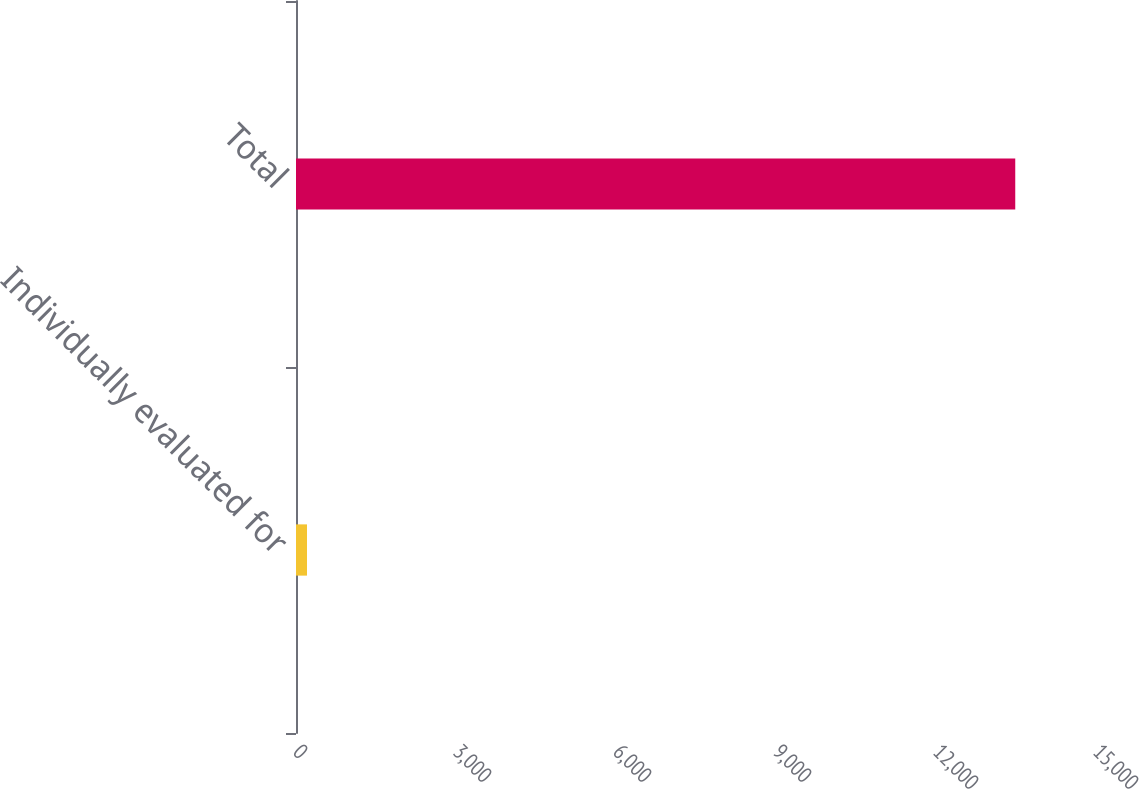<chart> <loc_0><loc_0><loc_500><loc_500><bar_chart><fcel>Individually evaluated for<fcel>Total<nl><fcel>206<fcel>13486<nl></chart> 